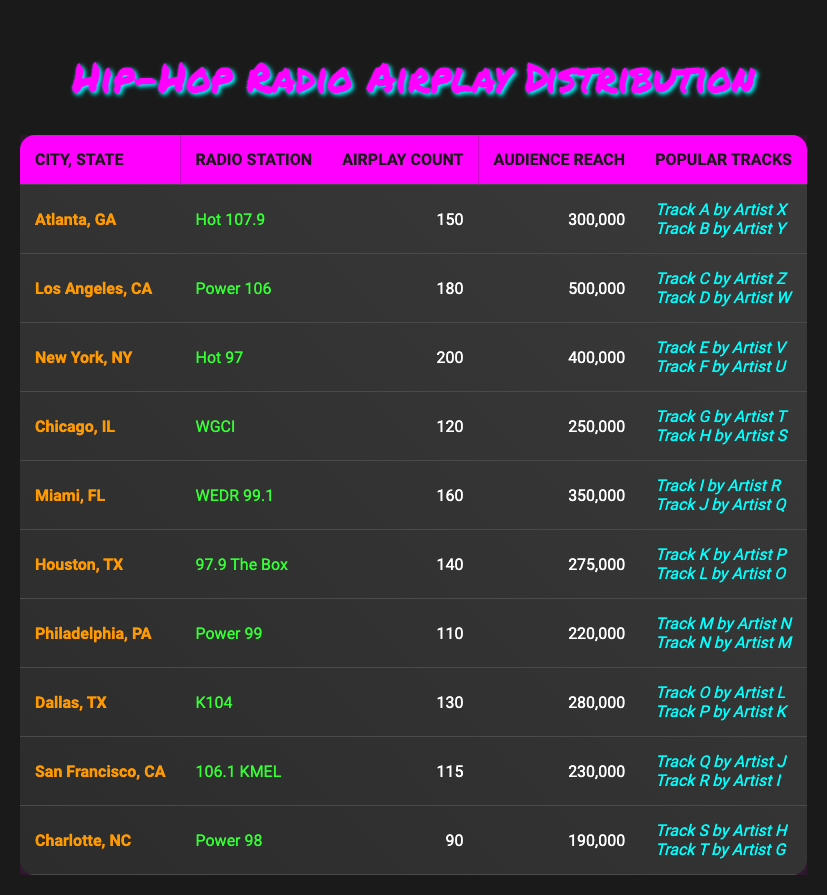What city has the highest airplay count for emerging hip-hop tracks? By looking at the Airplay Count column, we can identify the maximum value. New York has an airplay count of 200, which is the highest among all listed cities.
Answer: New York What is the total audience reach for all radio stations listed in the table? To find the total audience reach, we add up the Audience Reach values for each station: 300000 + 500000 + 400000 + 250000 + 350000 + 275000 + 220000 + 280000 + 230000 + 190000 = 2790000.
Answer: 2790000 Which radio station in Houston has played more emerging hip-hop tracks? From the table, the radio station in Houston listed is 97.9 The Box, and it has an airplay count of 140. There are no other entries for Houston, so this is the only one.
Answer: Yes Is there a city listed that has an airplay count below 100? By checking the Airplay Count values, only Charlotte, NC has an airplay count of 90, which is below 100.
Answer: Yes Which city has the lowest audience reach? We compare the Audience Reach values from all cities: Charlotte has the lowest reach of 190000, making it the city with the least audience reach in the data.
Answer: Charlotte What is the average airplay count across all cities? To find the average, we add all the airplay counts: 150 + 180 + 200 + 120 + 160 + 140 + 110 + 130 + 115 + 90 = 1395. Then divide by the number of cities (10): 1395/10 = 139.5.
Answer: 139.5 Which city has the highest audience reach and what is the value? By looking through the Audience Reach values, Los Angeles has the highest at 500000, while comparing it to others shows New York follows with 400000.
Answer: Los Angeles, 500000 Does the city of Atlanta list more popular tracks than the city of Philadelphia? Atlanta has 2 popular tracks listed while Philadelphia has 2 as well. Therefore, they are equal.
Answer: No What are the popular tracks from Miami's radio station? Miami's radio station, WEDR 99.1, lists Track I by Artist R and Track J by Artist Q as its popular tracks.
Answer: Track I by Artist R, Track J by Artist Q 